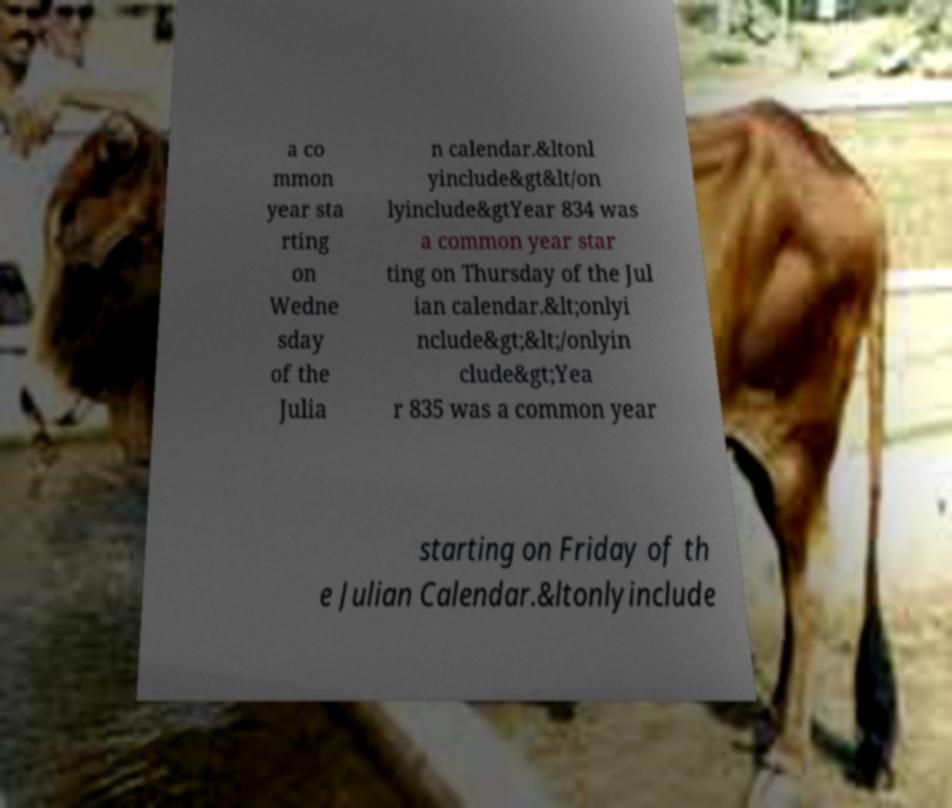There's text embedded in this image that I need extracted. Can you transcribe it verbatim? a co mmon year sta rting on Wedne sday of the Julia n calendar.&ltonl yinclude&gt&lt/on lyinclude&gtYear 834 was a common year star ting on Thursday of the Jul ian calendar.&lt;onlyi nclude&gt;&lt;/onlyin clude&gt;Yea r 835 was a common year starting on Friday of th e Julian Calendar.&ltonlyinclude 